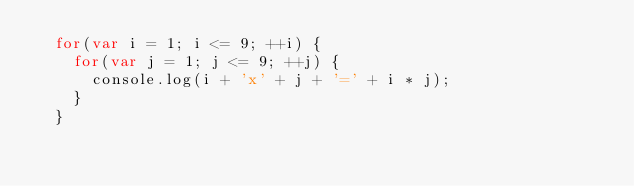Convert code to text. <code><loc_0><loc_0><loc_500><loc_500><_JavaScript_>	for(var i = 1; i <= 9; ++i) {
		for(var j = 1; j <= 9; ++j) {
			console.log(i + 'x' + j + '=' + i * j);
		}
	}</code> 